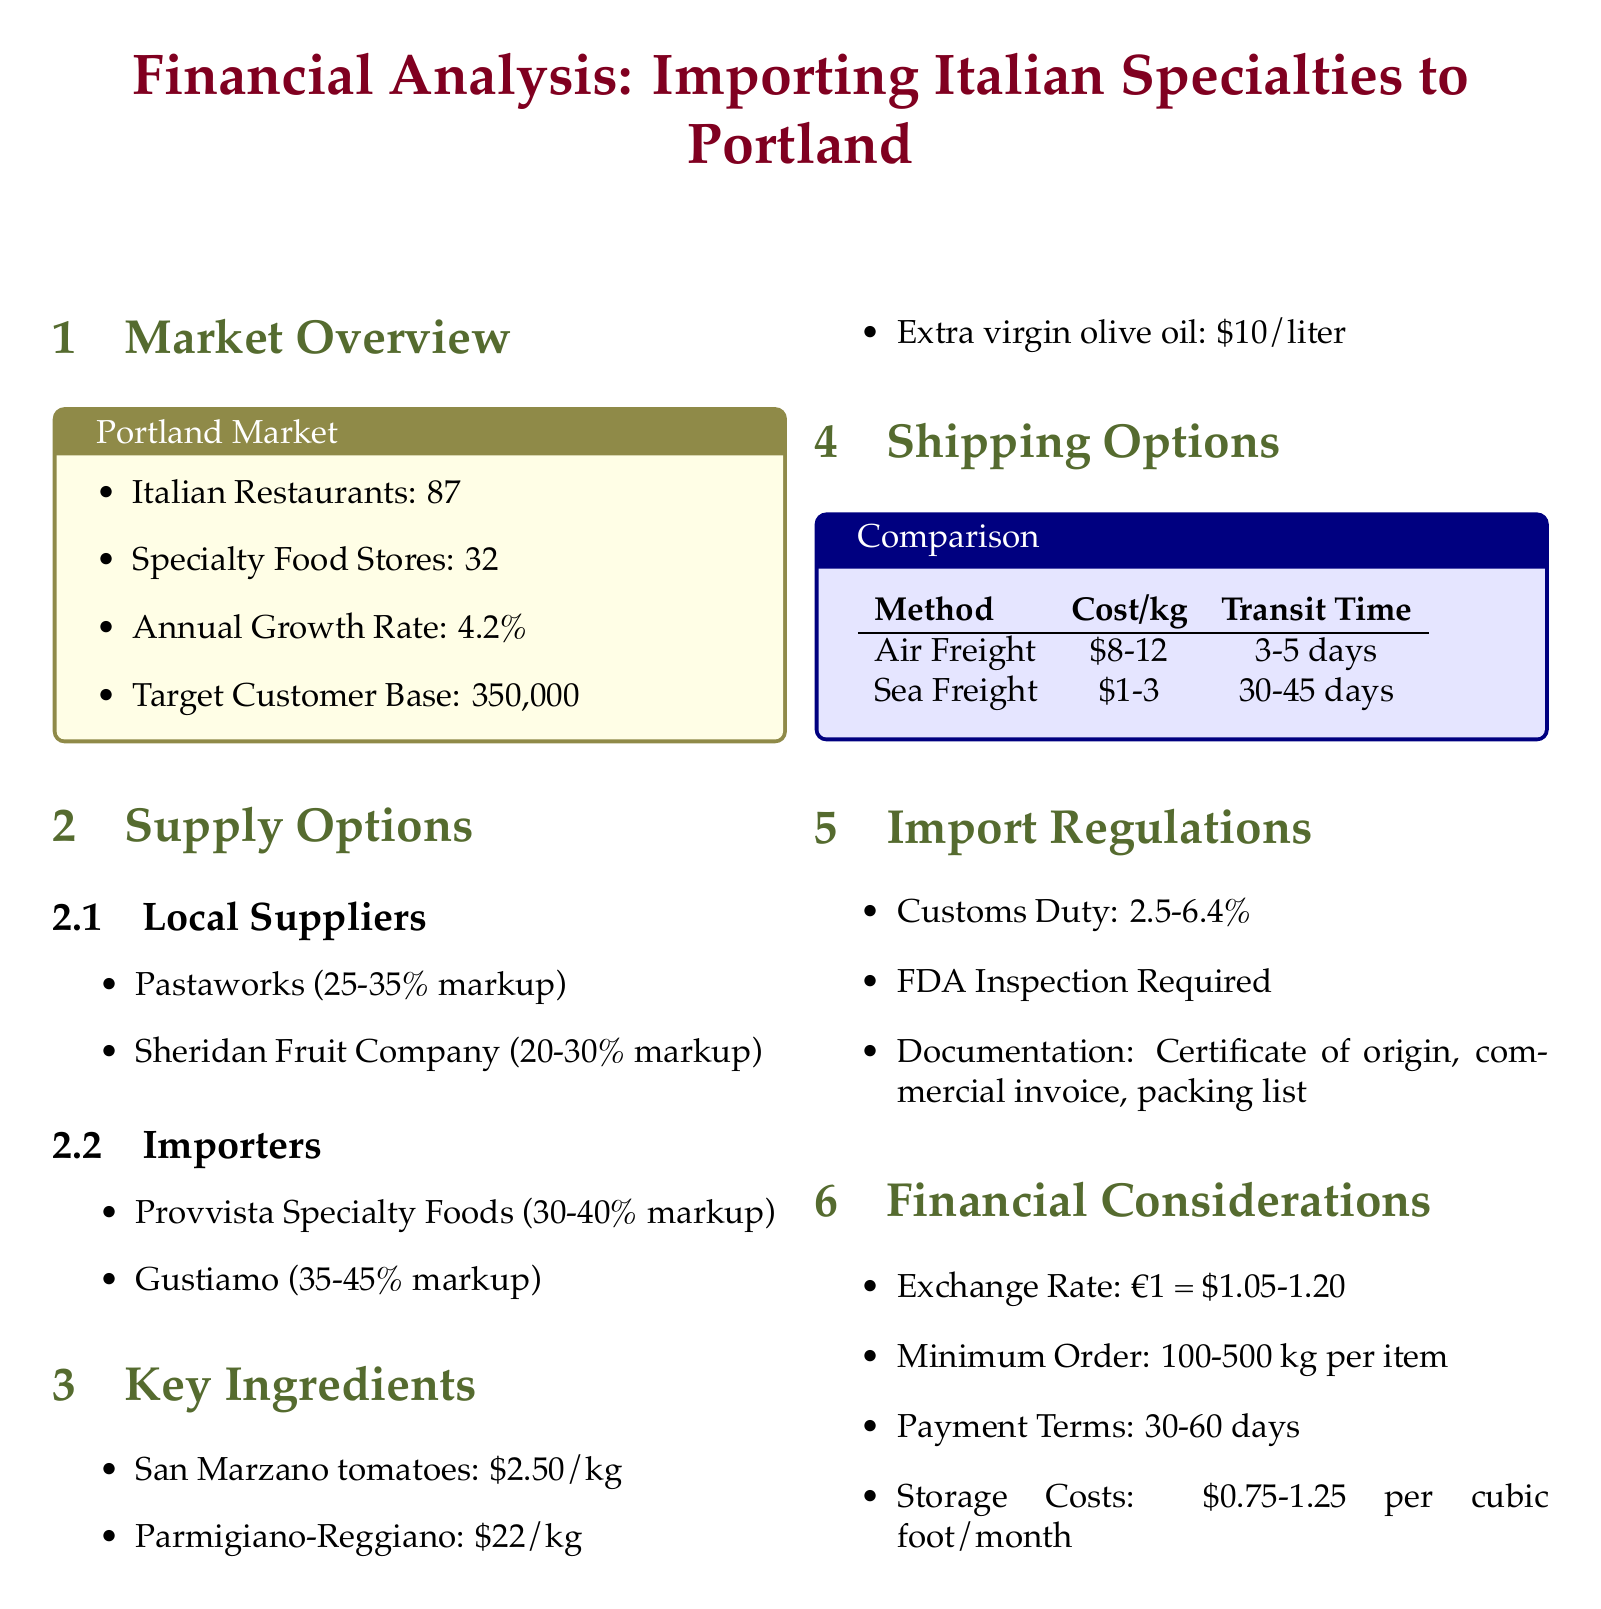What is the markup range for Pastaworks? The markup range for Pastaworks, a local supplier, is 25-35%.
Answer: 25-35% What is the average annual growth rate for the market? The annual growth rate for the market is provided as a percentage, which is 4.2%.
Answer: 4.2% What is the wholesale price of Extra virgin olive oil? The wholesale price of Extra virgin olive oil is stated in the document as $10 per liter.
Answer: $10/liter What is the shipping cost range for Air freight? The document specifies that the cost per kg for Air freight ranges from $8 to $12.
Answer: $8-12 How many Italian restaurants are there in Portland? The number of Italian restaurants listed in the market overview is 87.
Answer: 87 What documents are required for importation? The document lists the required documentation for importation as a Certificate of origin, commercial invoice, and packing list.
Answer: Certificate of origin, commercial invoice, packing list How long does Sea freight take for transit? The transit time for Sea freight is provided in the document as 30-45 days.
Answer: 30-45 days What is the customs duty percentage range? The customs duty percentage range mentioned in the document is 2.5-6.4%.
Answer: 2.5-6.4% What is the minimum order quantity for imported items? The minimum order quantity for imported items is specified as usually 100-500 kg per item.
Answer: 100-500 kg 